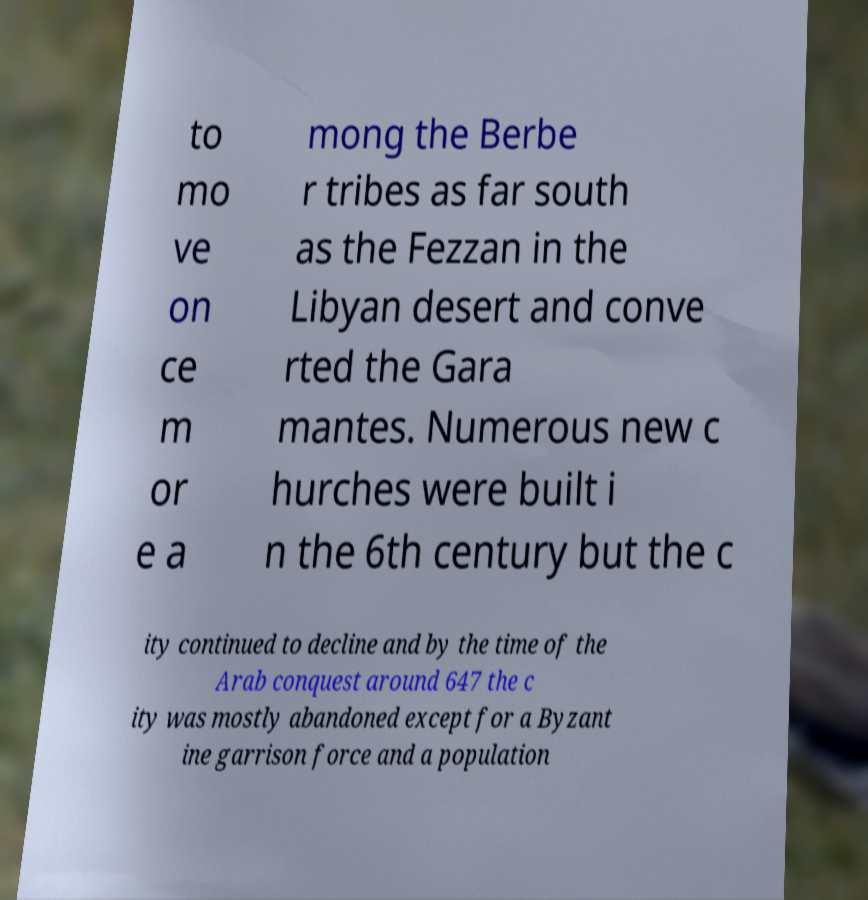For documentation purposes, I need the text within this image transcribed. Could you provide that? to mo ve on ce m or e a mong the Berbe r tribes as far south as the Fezzan in the Libyan desert and conve rted the Gara mantes. Numerous new c hurches were built i n the 6th century but the c ity continued to decline and by the time of the Arab conquest around 647 the c ity was mostly abandoned except for a Byzant ine garrison force and a population 